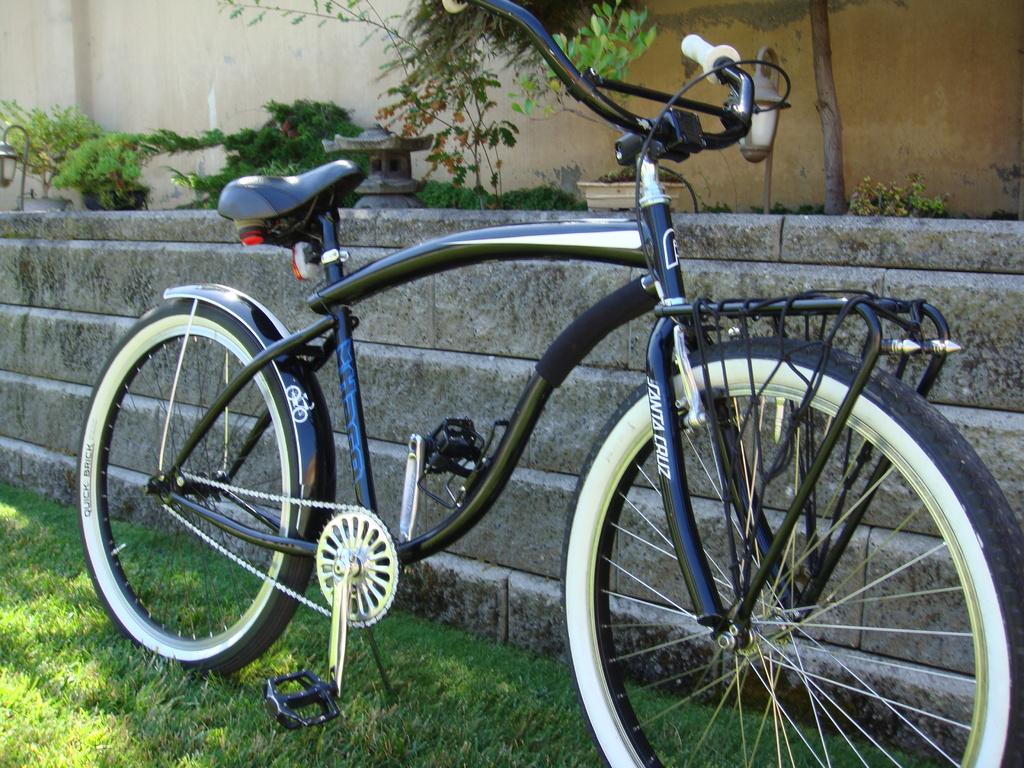What is the main object in the image? There is a cycle in the image. How is the cycle positioned in the image? The cycle is parked on the ground. What type of surface is the cycle parked on? There is grass on the ground. What can be seen on the cycle? There is text on the cycle. What is behind the cycle in the image? There is a wall behind the cycle. What is visible behind the wall? There are plants behind the wall. How many women are coughing in the image? There are no women or coughing sounds present in the image. 